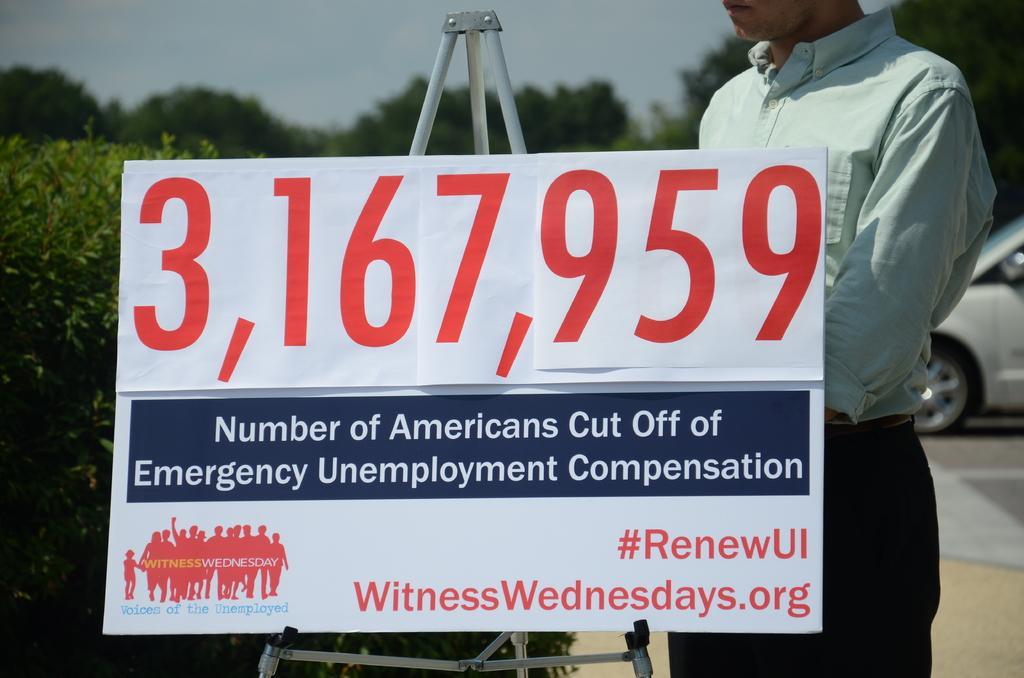Describe this image in one or two sentences. In this image I can see a tripod stand and on it I can see a white colour board. I can also see something is written on the board and behind it I can see a man is standing. On the left side I can see a plant and in the background I can see number of trees, a car and the sky. 